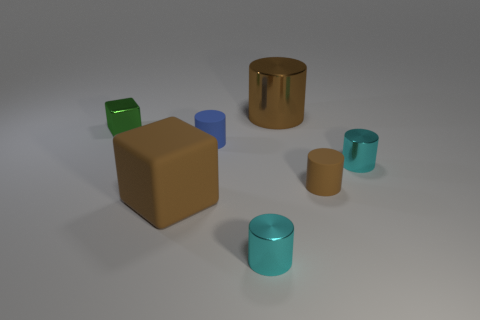Subtract 1 cylinders. How many cylinders are left? 4 Subtract all blue cylinders. How many cylinders are left? 4 Subtract all large brown metallic cylinders. How many cylinders are left? 4 Subtract all blue cylinders. Subtract all brown balls. How many cylinders are left? 4 Add 1 tiny blocks. How many objects exist? 8 Subtract all cylinders. How many objects are left? 2 Add 4 large brown matte blocks. How many large brown matte blocks exist? 5 Subtract 0 blue blocks. How many objects are left? 7 Subtract all small cyan shiny objects. Subtract all small brown cylinders. How many objects are left? 4 Add 1 small blocks. How many small blocks are left? 2 